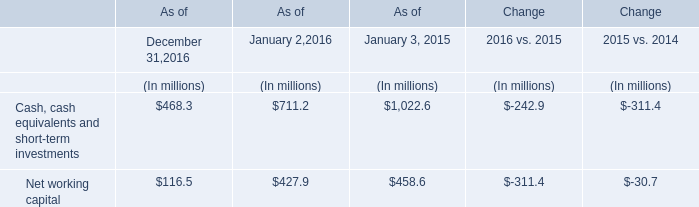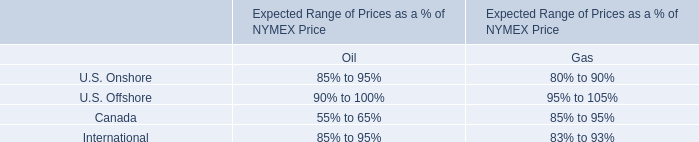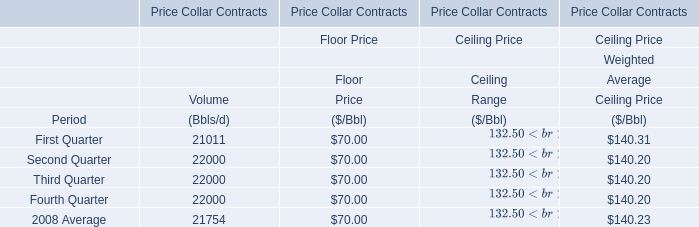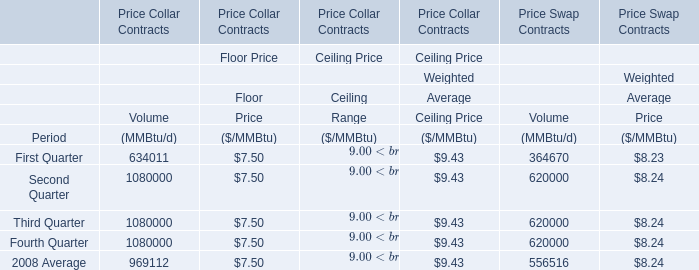In the Quarter with lowest amount of Volume, what's the amount of Weighted Average Ceiling Price? 
Answer: 140.31. What is the difference between the greatest Volume in First Quarter, 2008 and Second Quarter, 2008？ 
Computations: (634011 - 1080000)
Answer: -445989.0. 